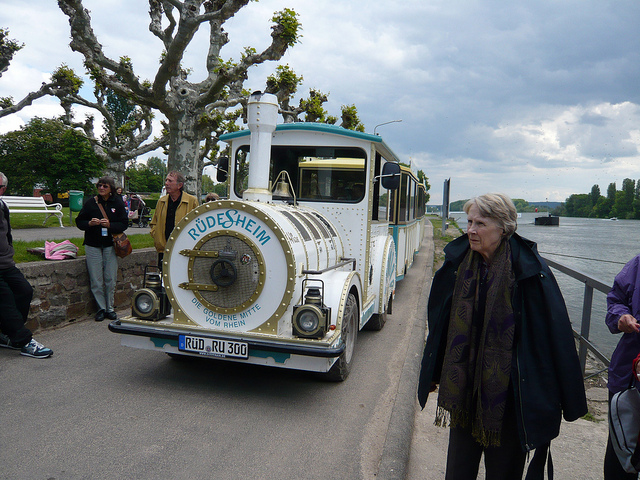<image>What type of trees are on the raised area? I am not sure about the type of trees on the raised area. It could be birch, willow, olive, oak, elm or others. What type of trees are on the raised area? I am not sure what type of trees are on the raised area. Some possibilities are birch, willow, olive, oak, and elm. 